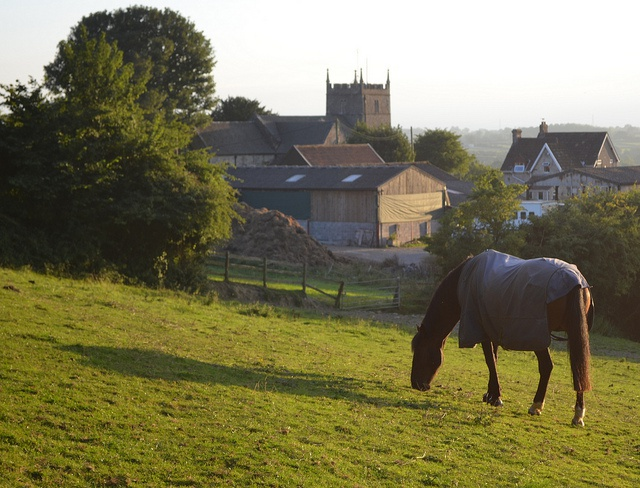Describe the objects in this image and their specific colors. I can see a horse in white, black, gray, maroon, and olive tones in this image. 